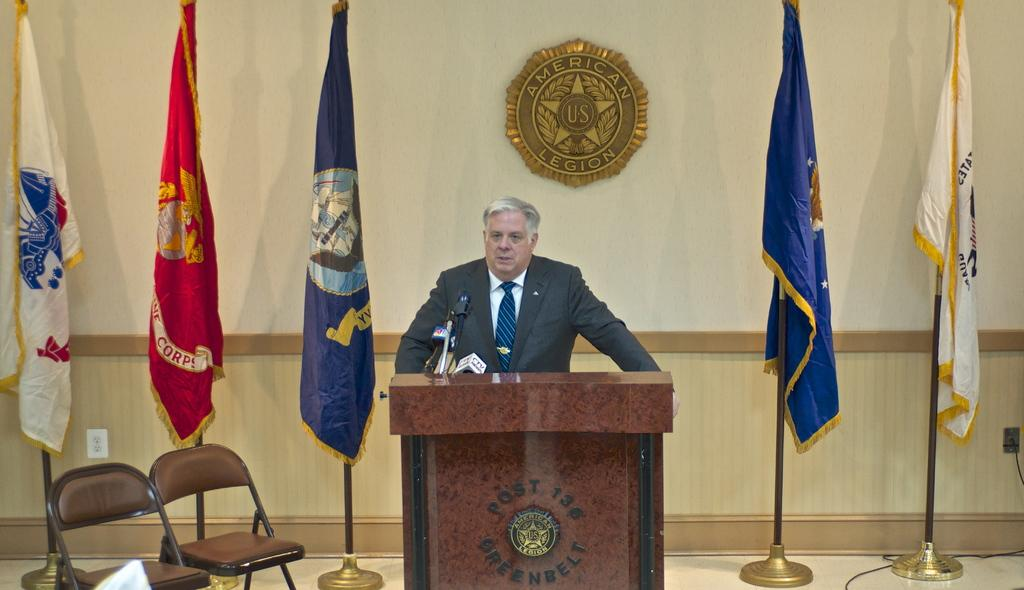What is the main subject of the image? There is a person standing at the center of the image. What can be seen on either side of the person? There are flags on the left and right sides of the person. What text is visible in the background of the image? The text "American U. S. Legion" is written on a wall in the background of the image. Who is the owner of the magic wand in the image? There is no magic wand present in the image. What type of branch is the person holding in the image? There is no branch visible in the image; the person is standing between two flags. 